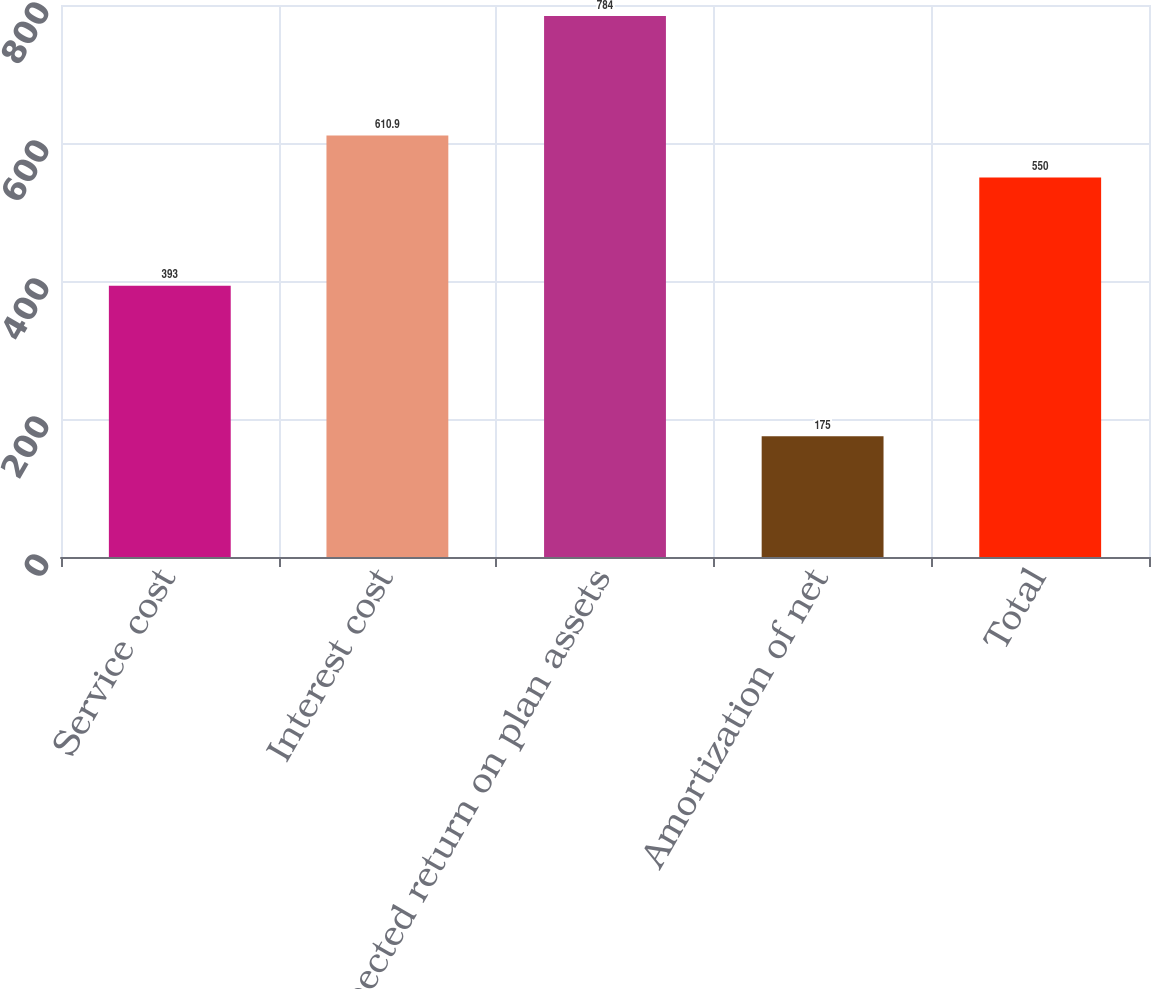Convert chart. <chart><loc_0><loc_0><loc_500><loc_500><bar_chart><fcel>Service cost<fcel>Interest cost<fcel>Expected return on plan assets<fcel>Amortization of net<fcel>Total<nl><fcel>393<fcel>610.9<fcel>784<fcel>175<fcel>550<nl></chart> 